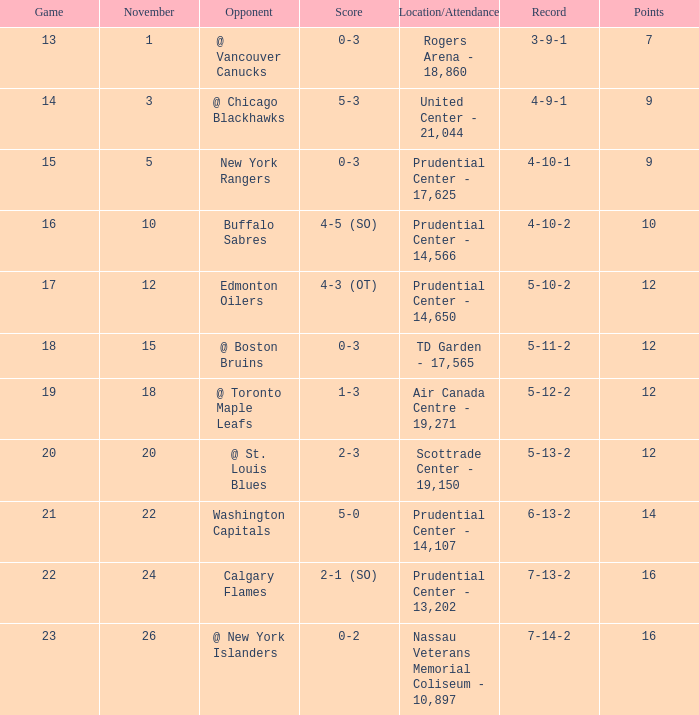What is the record that had a score of 5-3? 4-9-1. Write the full table. {'header': ['Game', 'November', 'Opponent', 'Score', 'Location/Attendance', 'Record', 'Points'], 'rows': [['13', '1', '@ Vancouver Canucks', '0-3', 'Rogers Arena - 18,860', '3-9-1', '7'], ['14', '3', '@ Chicago Blackhawks', '5-3', 'United Center - 21,044', '4-9-1', '9'], ['15', '5', 'New York Rangers', '0-3', 'Prudential Center - 17,625', '4-10-1', '9'], ['16', '10', 'Buffalo Sabres', '4-5 (SO)', 'Prudential Center - 14,566', '4-10-2', '10'], ['17', '12', 'Edmonton Oilers', '4-3 (OT)', 'Prudential Center - 14,650', '5-10-2', '12'], ['18', '15', '@ Boston Bruins', '0-3', 'TD Garden - 17,565', '5-11-2', '12'], ['19', '18', '@ Toronto Maple Leafs', '1-3', 'Air Canada Centre - 19,271', '5-12-2', '12'], ['20', '20', '@ St. Louis Blues', '2-3', 'Scottrade Center - 19,150', '5-13-2', '12'], ['21', '22', 'Washington Capitals', '5-0', 'Prudential Center - 14,107', '6-13-2', '14'], ['22', '24', 'Calgary Flames', '2-1 (SO)', 'Prudential Center - 13,202', '7-13-2', '16'], ['23', '26', '@ New York Islanders', '0-2', 'Nassau Veterans Memorial Coliseum - 10,897', '7-14-2', '16']]} 